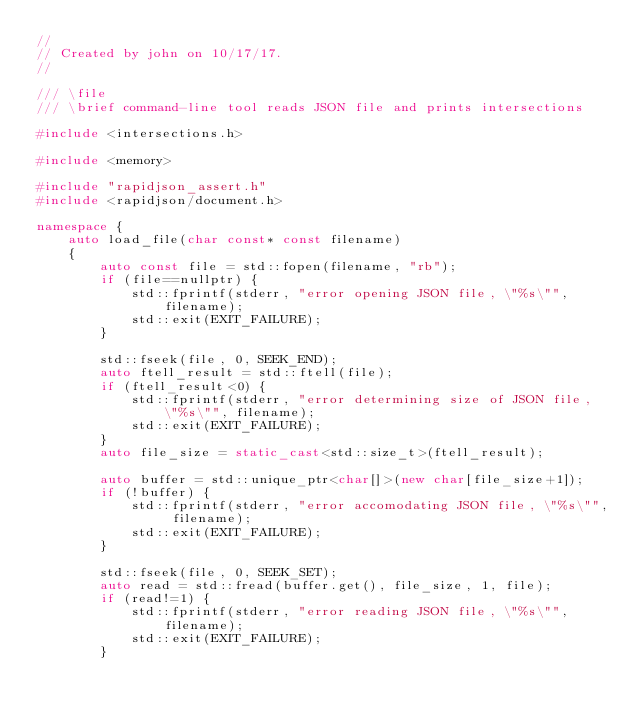Convert code to text. <code><loc_0><loc_0><loc_500><loc_500><_C++_>//
// Created by john on 10/17/17.
//

/// \file
/// \brief command-line tool reads JSON file and prints intersections

#include <intersections.h>

#include <memory>

#include "rapidjson_assert.h"
#include <rapidjson/document.h>

namespace {
    auto load_file(char const* const filename)
    {
        auto const file = std::fopen(filename, "rb");
        if (file==nullptr) {
            std::fprintf(stderr, "error opening JSON file, \"%s\"", filename);
            std::exit(EXIT_FAILURE);
        }

        std::fseek(file, 0, SEEK_END);
        auto ftell_result = std::ftell(file);
        if (ftell_result<0) {
            std::fprintf(stderr, "error determining size of JSON file, \"%s\"", filename);
            std::exit(EXIT_FAILURE);
        }
        auto file_size = static_cast<std::size_t>(ftell_result);

        auto buffer = std::unique_ptr<char[]>(new char[file_size+1]);
        if (!buffer) {
            std::fprintf(stderr, "error accomodating JSON file, \"%s\"", filename);
            std::exit(EXIT_FAILURE);
        }

        std::fseek(file, 0, SEEK_SET);
        auto read = std::fread(buffer.get(), file_size, 1, file);
        if (read!=1) {
            std::fprintf(stderr, "error reading JSON file, \"%s\"", filename);
            std::exit(EXIT_FAILURE);
        }</code> 